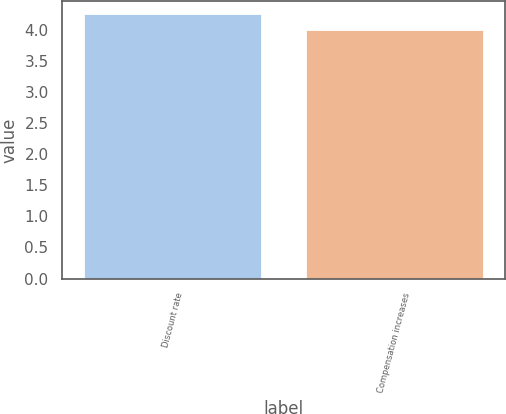Convert chart to OTSL. <chart><loc_0><loc_0><loc_500><loc_500><bar_chart><fcel>Discount rate<fcel>Compensation increases<nl><fcel>4.25<fcel>4<nl></chart> 